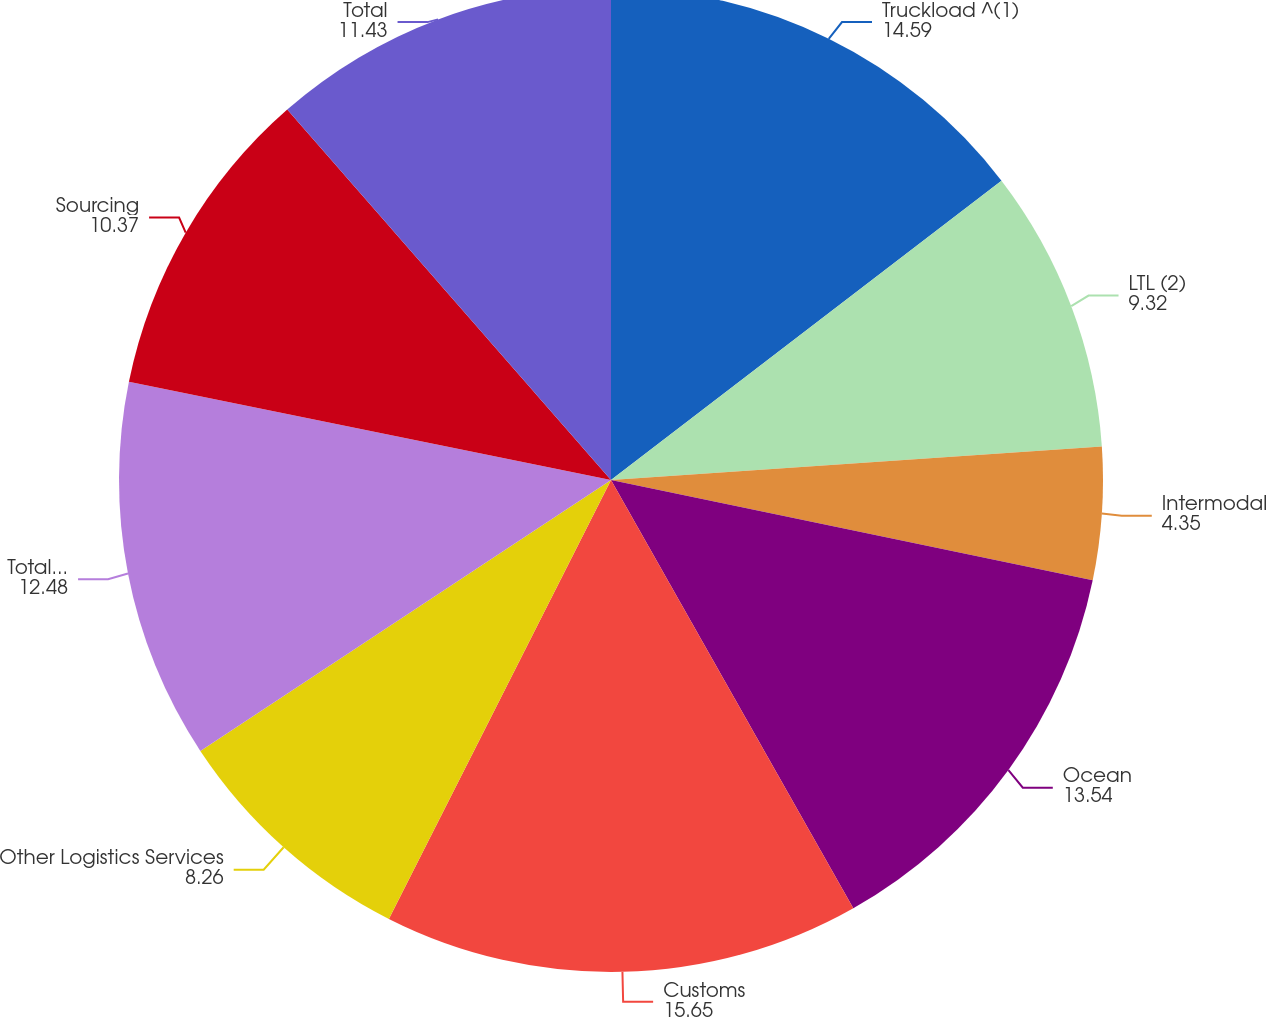Convert chart. <chart><loc_0><loc_0><loc_500><loc_500><pie_chart><fcel>Truckload ^(1)<fcel>LTL (2)<fcel>Intermodal<fcel>Ocean<fcel>Customs<fcel>Other Logistics Services<fcel>Total Transportation<fcel>Sourcing<fcel>Total<nl><fcel>14.59%<fcel>9.32%<fcel>4.35%<fcel>13.54%<fcel>15.65%<fcel>8.26%<fcel>12.48%<fcel>10.37%<fcel>11.43%<nl></chart> 